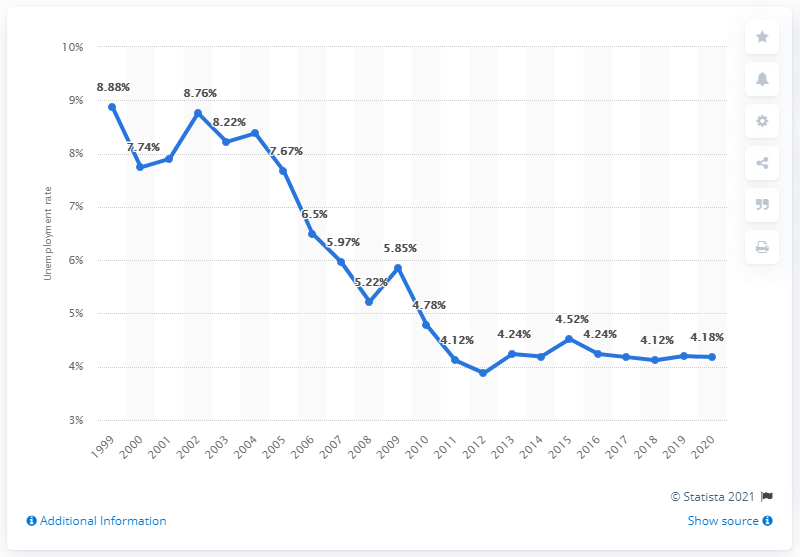Identify some key points in this picture. In 2020, the unemployment rate in Sri Lanka was 4.18%. 